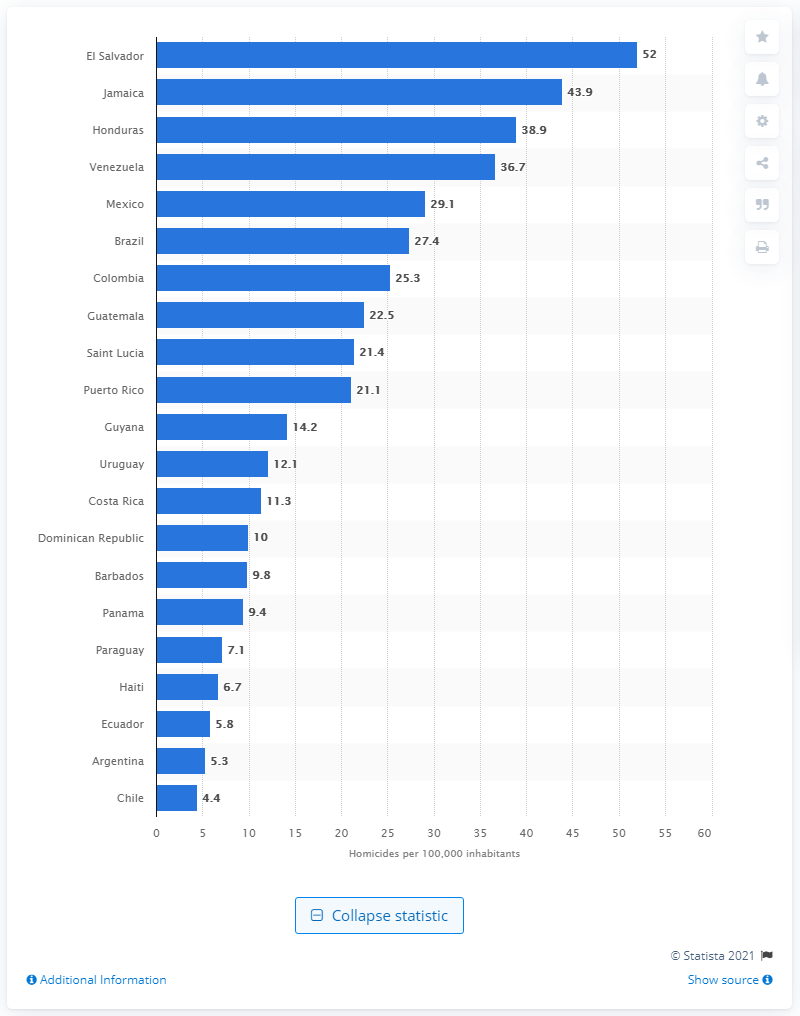List a handful of essential elements in this visual. Brazil had the highest number of homicide victims among all countries in the year 2020. According to data, Jamaica ranked second in homicides per 100,000 inhabitants among all countries. 